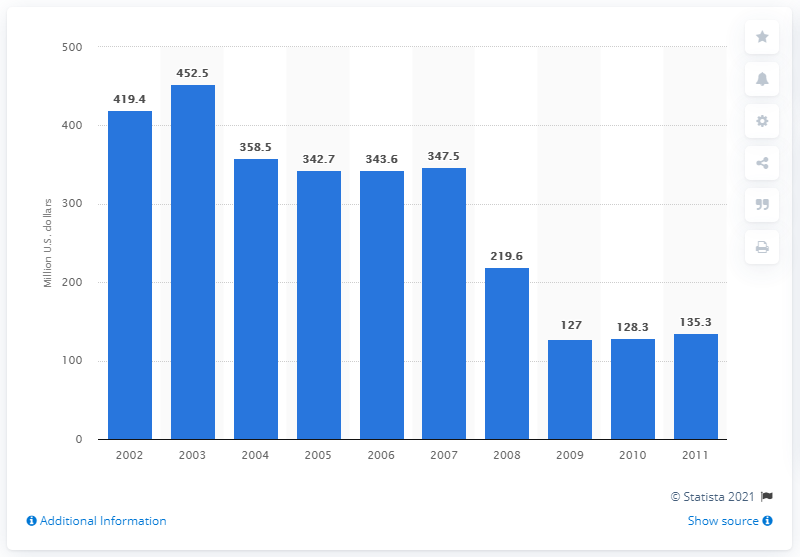Draw attention to some important aspects in this diagram. The value of U.S. product shipments of gift wrap paper in 2009 was $127 million. 